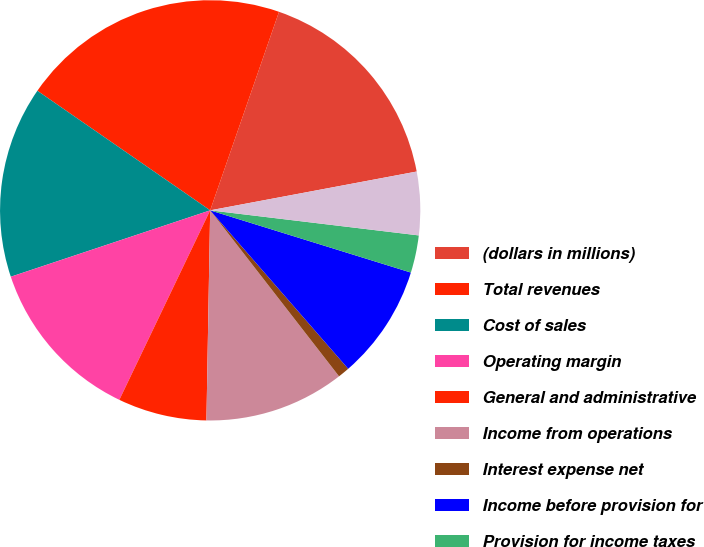Convert chart. <chart><loc_0><loc_0><loc_500><loc_500><pie_chart><fcel>(dollars in millions)<fcel>Total revenues<fcel>Cost of sales<fcel>Operating margin<fcel>General and administrative<fcel>Income from operations<fcel>Interest expense net<fcel>Income before provision for<fcel>Provision for income taxes<fcel>Net income<nl><fcel>16.73%<fcel>20.68%<fcel>14.75%<fcel>12.77%<fcel>6.83%<fcel>10.79%<fcel>0.9%<fcel>8.81%<fcel>2.88%<fcel>4.86%<nl></chart> 